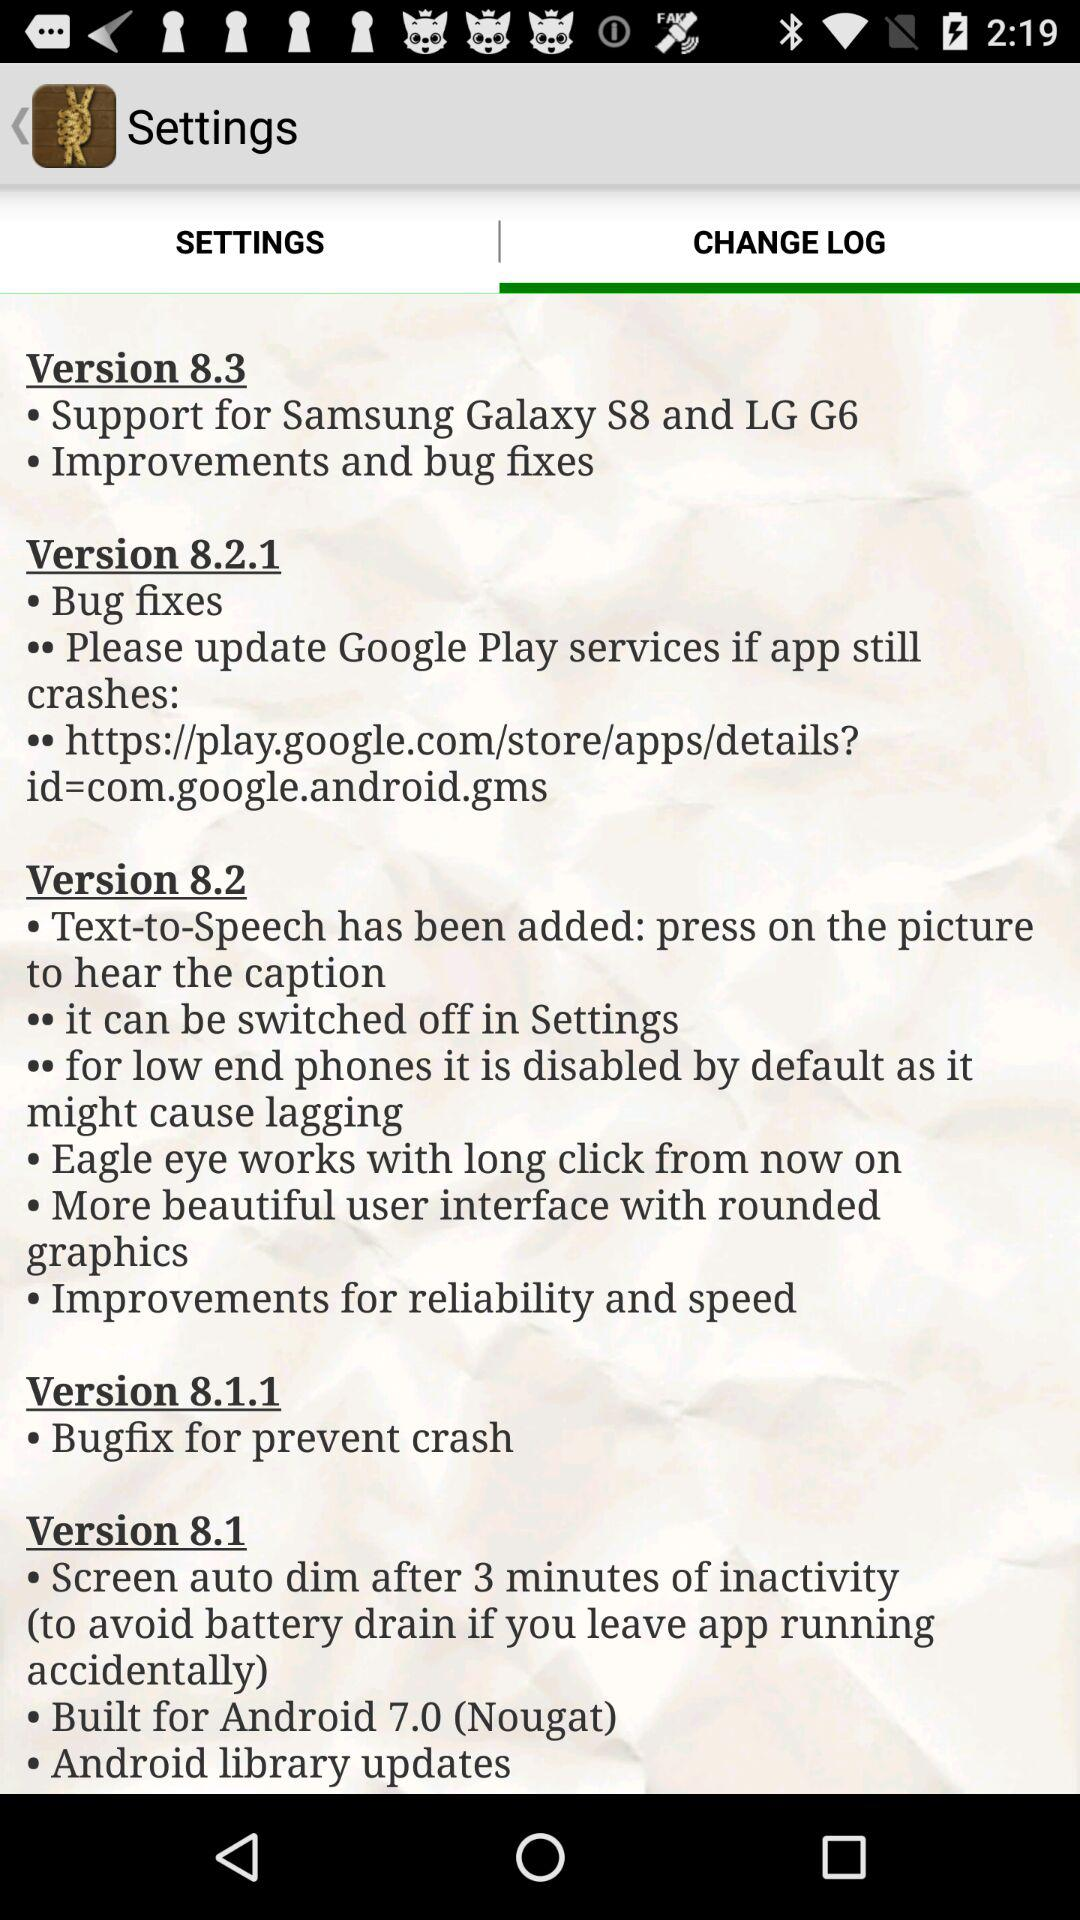What is the feature of version 8.2.1? Version 8.2.1's feature is bug fixes. 